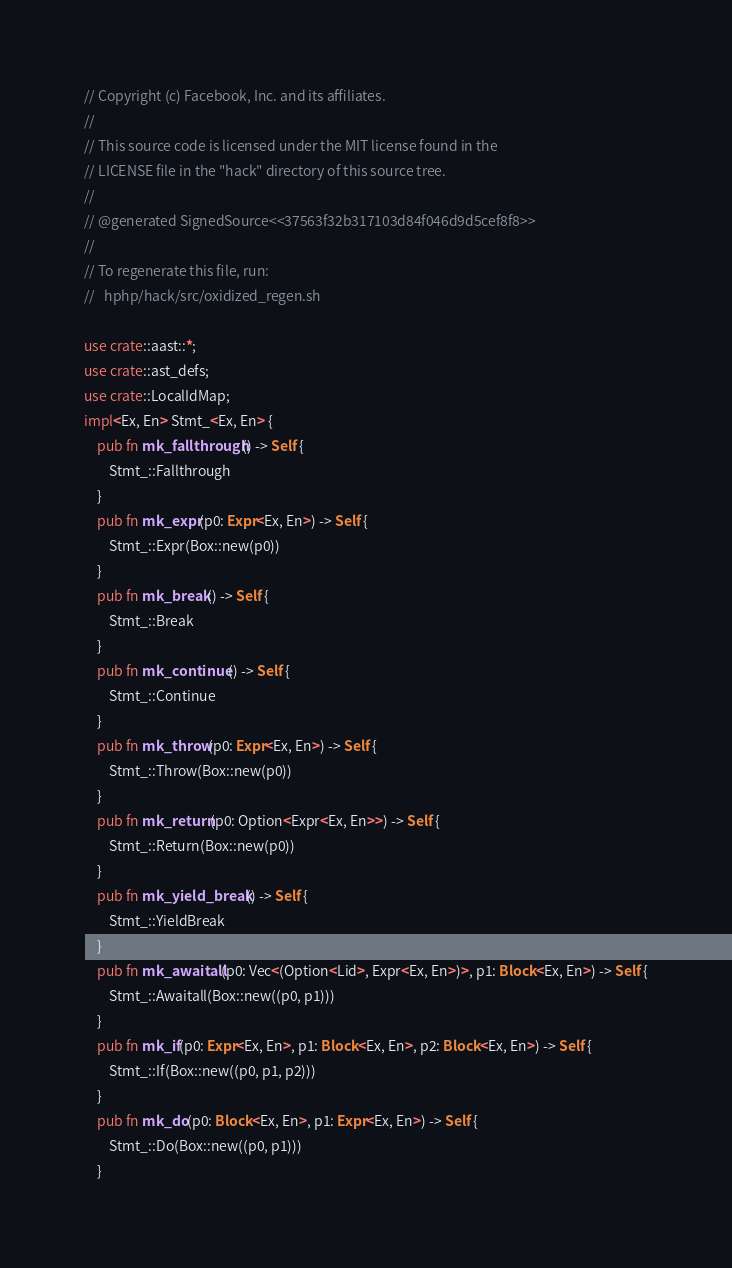Convert code to text. <code><loc_0><loc_0><loc_500><loc_500><_Rust_>// Copyright (c) Facebook, Inc. and its affiliates.
//
// This source code is licensed under the MIT license found in the
// LICENSE file in the "hack" directory of this source tree.
//
// @generated SignedSource<<37563f32b317103d84f046d9d5cef8f8>>
//
// To regenerate this file, run:
//   hphp/hack/src/oxidized_regen.sh

use crate::aast::*;
use crate::ast_defs;
use crate::LocalIdMap;
impl<Ex, En> Stmt_<Ex, En> {
    pub fn mk_fallthrough() -> Self {
        Stmt_::Fallthrough
    }
    pub fn mk_expr(p0: Expr<Ex, En>) -> Self {
        Stmt_::Expr(Box::new(p0))
    }
    pub fn mk_break() -> Self {
        Stmt_::Break
    }
    pub fn mk_continue() -> Self {
        Stmt_::Continue
    }
    pub fn mk_throw(p0: Expr<Ex, En>) -> Self {
        Stmt_::Throw(Box::new(p0))
    }
    pub fn mk_return(p0: Option<Expr<Ex, En>>) -> Self {
        Stmt_::Return(Box::new(p0))
    }
    pub fn mk_yield_break() -> Self {
        Stmt_::YieldBreak
    }
    pub fn mk_awaitall(p0: Vec<(Option<Lid>, Expr<Ex, En>)>, p1: Block<Ex, En>) -> Self {
        Stmt_::Awaitall(Box::new((p0, p1)))
    }
    pub fn mk_if(p0: Expr<Ex, En>, p1: Block<Ex, En>, p2: Block<Ex, En>) -> Self {
        Stmt_::If(Box::new((p0, p1, p2)))
    }
    pub fn mk_do(p0: Block<Ex, En>, p1: Expr<Ex, En>) -> Self {
        Stmt_::Do(Box::new((p0, p1)))
    }</code> 